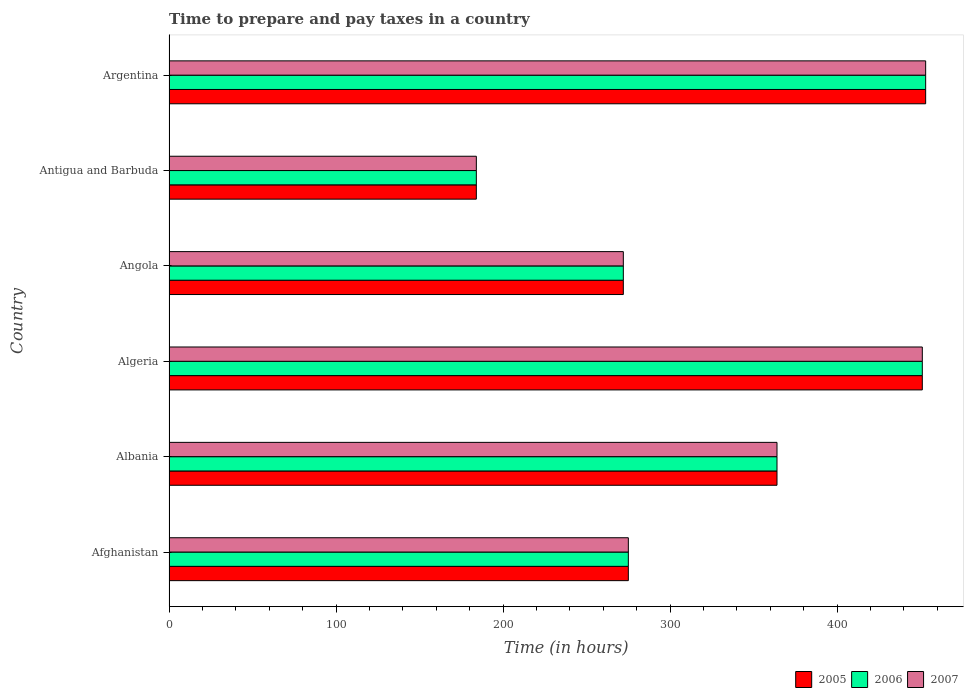How many different coloured bars are there?
Your answer should be compact. 3. How many groups of bars are there?
Offer a very short reply. 6. How many bars are there on the 2nd tick from the bottom?
Offer a terse response. 3. What is the label of the 4th group of bars from the top?
Ensure brevity in your answer.  Algeria. In how many cases, is the number of bars for a given country not equal to the number of legend labels?
Provide a short and direct response. 0. What is the number of hours required to prepare and pay taxes in 2005 in Argentina?
Provide a succinct answer. 453. Across all countries, what is the maximum number of hours required to prepare and pay taxes in 2006?
Offer a very short reply. 453. Across all countries, what is the minimum number of hours required to prepare and pay taxes in 2006?
Provide a succinct answer. 184. In which country was the number of hours required to prepare and pay taxes in 2006 minimum?
Keep it short and to the point. Antigua and Barbuda. What is the total number of hours required to prepare and pay taxes in 2005 in the graph?
Offer a very short reply. 1999. What is the difference between the number of hours required to prepare and pay taxes in 2007 in Angola and that in Argentina?
Your answer should be very brief. -181. What is the difference between the number of hours required to prepare and pay taxes in 2006 in Algeria and the number of hours required to prepare and pay taxes in 2007 in Angola?
Make the answer very short. 179. What is the average number of hours required to prepare and pay taxes in 2007 per country?
Your answer should be compact. 333.17. In how many countries, is the number of hours required to prepare and pay taxes in 2005 greater than 360 hours?
Keep it short and to the point. 3. What is the ratio of the number of hours required to prepare and pay taxes in 2005 in Afghanistan to that in Argentina?
Provide a short and direct response. 0.61. What is the difference between the highest and the lowest number of hours required to prepare and pay taxes in 2007?
Offer a terse response. 269. Is the sum of the number of hours required to prepare and pay taxes in 2007 in Afghanistan and Argentina greater than the maximum number of hours required to prepare and pay taxes in 2005 across all countries?
Offer a very short reply. Yes. What does the 1st bar from the top in Antigua and Barbuda represents?
Give a very brief answer. 2007. How many bars are there?
Your response must be concise. 18. Are all the bars in the graph horizontal?
Ensure brevity in your answer.  Yes. How many countries are there in the graph?
Offer a terse response. 6. What is the difference between two consecutive major ticks on the X-axis?
Keep it short and to the point. 100. Does the graph contain any zero values?
Offer a terse response. No. Where does the legend appear in the graph?
Provide a succinct answer. Bottom right. How are the legend labels stacked?
Make the answer very short. Horizontal. What is the title of the graph?
Your answer should be compact. Time to prepare and pay taxes in a country. What is the label or title of the X-axis?
Your answer should be compact. Time (in hours). What is the label or title of the Y-axis?
Give a very brief answer. Country. What is the Time (in hours) in 2005 in Afghanistan?
Make the answer very short. 275. What is the Time (in hours) of 2006 in Afghanistan?
Keep it short and to the point. 275. What is the Time (in hours) of 2007 in Afghanistan?
Offer a terse response. 275. What is the Time (in hours) in 2005 in Albania?
Provide a succinct answer. 364. What is the Time (in hours) of 2006 in Albania?
Provide a short and direct response. 364. What is the Time (in hours) in 2007 in Albania?
Offer a very short reply. 364. What is the Time (in hours) of 2005 in Algeria?
Provide a short and direct response. 451. What is the Time (in hours) in 2006 in Algeria?
Provide a succinct answer. 451. What is the Time (in hours) in 2007 in Algeria?
Ensure brevity in your answer.  451. What is the Time (in hours) in 2005 in Angola?
Provide a succinct answer. 272. What is the Time (in hours) of 2006 in Angola?
Provide a short and direct response. 272. What is the Time (in hours) of 2007 in Angola?
Ensure brevity in your answer.  272. What is the Time (in hours) of 2005 in Antigua and Barbuda?
Your response must be concise. 184. What is the Time (in hours) in 2006 in Antigua and Barbuda?
Your answer should be compact. 184. What is the Time (in hours) of 2007 in Antigua and Barbuda?
Offer a terse response. 184. What is the Time (in hours) in 2005 in Argentina?
Offer a terse response. 453. What is the Time (in hours) in 2006 in Argentina?
Offer a terse response. 453. What is the Time (in hours) in 2007 in Argentina?
Offer a very short reply. 453. Across all countries, what is the maximum Time (in hours) of 2005?
Give a very brief answer. 453. Across all countries, what is the maximum Time (in hours) in 2006?
Offer a terse response. 453. Across all countries, what is the maximum Time (in hours) of 2007?
Provide a short and direct response. 453. Across all countries, what is the minimum Time (in hours) of 2005?
Make the answer very short. 184. Across all countries, what is the minimum Time (in hours) in 2006?
Your response must be concise. 184. Across all countries, what is the minimum Time (in hours) of 2007?
Provide a succinct answer. 184. What is the total Time (in hours) of 2005 in the graph?
Your response must be concise. 1999. What is the total Time (in hours) of 2006 in the graph?
Offer a terse response. 1999. What is the total Time (in hours) of 2007 in the graph?
Give a very brief answer. 1999. What is the difference between the Time (in hours) in 2005 in Afghanistan and that in Albania?
Offer a very short reply. -89. What is the difference between the Time (in hours) of 2006 in Afghanistan and that in Albania?
Give a very brief answer. -89. What is the difference between the Time (in hours) in 2007 in Afghanistan and that in Albania?
Give a very brief answer. -89. What is the difference between the Time (in hours) in 2005 in Afghanistan and that in Algeria?
Your answer should be compact. -176. What is the difference between the Time (in hours) in 2006 in Afghanistan and that in Algeria?
Give a very brief answer. -176. What is the difference between the Time (in hours) of 2007 in Afghanistan and that in Algeria?
Offer a very short reply. -176. What is the difference between the Time (in hours) in 2007 in Afghanistan and that in Angola?
Your answer should be compact. 3. What is the difference between the Time (in hours) in 2005 in Afghanistan and that in Antigua and Barbuda?
Offer a very short reply. 91. What is the difference between the Time (in hours) of 2006 in Afghanistan and that in Antigua and Barbuda?
Your response must be concise. 91. What is the difference between the Time (in hours) in 2007 in Afghanistan and that in Antigua and Barbuda?
Your response must be concise. 91. What is the difference between the Time (in hours) in 2005 in Afghanistan and that in Argentina?
Offer a very short reply. -178. What is the difference between the Time (in hours) in 2006 in Afghanistan and that in Argentina?
Make the answer very short. -178. What is the difference between the Time (in hours) in 2007 in Afghanistan and that in Argentina?
Offer a very short reply. -178. What is the difference between the Time (in hours) in 2005 in Albania and that in Algeria?
Keep it short and to the point. -87. What is the difference between the Time (in hours) in 2006 in Albania and that in Algeria?
Offer a terse response. -87. What is the difference between the Time (in hours) of 2007 in Albania and that in Algeria?
Your response must be concise. -87. What is the difference between the Time (in hours) of 2005 in Albania and that in Angola?
Provide a succinct answer. 92. What is the difference between the Time (in hours) in 2006 in Albania and that in Angola?
Keep it short and to the point. 92. What is the difference between the Time (in hours) of 2007 in Albania and that in Angola?
Your answer should be very brief. 92. What is the difference between the Time (in hours) in 2005 in Albania and that in Antigua and Barbuda?
Your response must be concise. 180. What is the difference between the Time (in hours) in 2006 in Albania and that in Antigua and Barbuda?
Make the answer very short. 180. What is the difference between the Time (in hours) of 2007 in Albania and that in Antigua and Barbuda?
Give a very brief answer. 180. What is the difference between the Time (in hours) in 2005 in Albania and that in Argentina?
Your response must be concise. -89. What is the difference between the Time (in hours) of 2006 in Albania and that in Argentina?
Your response must be concise. -89. What is the difference between the Time (in hours) in 2007 in Albania and that in Argentina?
Ensure brevity in your answer.  -89. What is the difference between the Time (in hours) in 2005 in Algeria and that in Angola?
Your answer should be compact. 179. What is the difference between the Time (in hours) of 2006 in Algeria and that in Angola?
Offer a terse response. 179. What is the difference between the Time (in hours) of 2007 in Algeria and that in Angola?
Provide a short and direct response. 179. What is the difference between the Time (in hours) of 2005 in Algeria and that in Antigua and Barbuda?
Offer a terse response. 267. What is the difference between the Time (in hours) in 2006 in Algeria and that in Antigua and Barbuda?
Offer a terse response. 267. What is the difference between the Time (in hours) of 2007 in Algeria and that in Antigua and Barbuda?
Your response must be concise. 267. What is the difference between the Time (in hours) of 2005 in Angola and that in Argentina?
Your response must be concise. -181. What is the difference between the Time (in hours) of 2006 in Angola and that in Argentina?
Offer a terse response. -181. What is the difference between the Time (in hours) in 2007 in Angola and that in Argentina?
Provide a succinct answer. -181. What is the difference between the Time (in hours) in 2005 in Antigua and Barbuda and that in Argentina?
Your answer should be compact. -269. What is the difference between the Time (in hours) in 2006 in Antigua and Barbuda and that in Argentina?
Provide a short and direct response. -269. What is the difference between the Time (in hours) of 2007 in Antigua and Barbuda and that in Argentina?
Keep it short and to the point. -269. What is the difference between the Time (in hours) of 2005 in Afghanistan and the Time (in hours) of 2006 in Albania?
Keep it short and to the point. -89. What is the difference between the Time (in hours) in 2005 in Afghanistan and the Time (in hours) in 2007 in Albania?
Ensure brevity in your answer.  -89. What is the difference between the Time (in hours) of 2006 in Afghanistan and the Time (in hours) of 2007 in Albania?
Ensure brevity in your answer.  -89. What is the difference between the Time (in hours) in 2005 in Afghanistan and the Time (in hours) in 2006 in Algeria?
Provide a succinct answer. -176. What is the difference between the Time (in hours) of 2005 in Afghanistan and the Time (in hours) of 2007 in Algeria?
Offer a very short reply. -176. What is the difference between the Time (in hours) of 2006 in Afghanistan and the Time (in hours) of 2007 in Algeria?
Your answer should be compact. -176. What is the difference between the Time (in hours) in 2006 in Afghanistan and the Time (in hours) in 2007 in Angola?
Provide a succinct answer. 3. What is the difference between the Time (in hours) in 2005 in Afghanistan and the Time (in hours) in 2006 in Antigua and Barbuda?
Offer a very short reply. 91. What is the difference between the Time (in hours) in 2005 in Afghanistan and the Time (in hours) in 2007 in Antigua and Barbuda?
Your answer should be compact. 91. What is the difference between the Time (in hours) of 2006 in Afghanistan and the Time (in hours) of 2007 in Antigua and Barbuda?
Your answer should be compact. 91. What is the difference between the Time (in hours) of 2005 in Afghanistan and the Time (in hours) of 2006 in Argentina?
Your response must be concise. -178. What is the difference between the Time (in hours) in 2005 in Afghanistan and the Time (in hours) in 2007 in Argentina?
Offer a very short reply. -178. What is the difference between the Time (in hours) in 2006 in Afghanistan and the Time (in hours) in 2007 in Argentina?
Make the answer very short. -178. What is the difference between the Time (in hours) in 2005 in Albania and the Time (in hours) in 2006 in Algeria?
Your answer should be very brief. -87. What is the difference between the Time (in hours) in 2005 in Albania and the Time (in hours) in 2007 in Algeria?
Your answer should be compact. -87. What is the difference between the Time (in hours) of 2006 in Albania and the Time (in hours) of 2007 in Algeria?
Your answer should be very brief. -87. What is the difference between the Time (in hours) of 2005 in Albania and the Time (in hours) of 2006 in Angola?
Ensure brevity in your answer.  92. What is the difference between the Time (in hours) in 2005 in Albania and the Time (in hours) in 2007 in Angola?
Your response must be concise. 92. What is the difference between the Time (in hours) of 2006 in Albania and the Time (in hours) of 2007 in Angola?
Ensure brevity in your answer.  92. What is the difference between the Time (in hours) of 2005 in Albania and the Time (in hours) of 2006 in Antigua and Barbuda?
Give a very brief answer. 180. What is the difference between the Time (in hours) in 2005 in Albania and the Time (in hours) in 2007 in Antigua and Barbuda?
Your response must be concise. 180. What is the difference between the Time (in hours) in 2006 in Albania and the Time (in hours) in 2007 in Antigua and Barbuda?
Give a very brief answer. 180. What is the difference between the Time (in hours) of 2005 in Albania and the Time (in hours) of 2006 in Argentina?
Offer a very short reply. -89. What is the difference between the Time (in hours) of 2005 in Albania and the Time (in hours) of 2007 in Argentina?
Your answer should be compact. -89. What is the difference between the Time (in hours) of 2006 in Albania and the Time (in hours) of 2007 in Argentina?
Provide a short and direct response. -89. What is the difference between the Time (in hours) of 2005 in Algeria and the Time (in hours) of 2006 in Angola?
Your response must be concise. 179. What is the difference between the Time (in hours) in 2005 in Algeria and the Time (in hours) in 2007 in Angola?
Give a very brief answer. 179. What is the difference between the Time (in hours) in 2006 in Algeria and the Time (in hours) in 2007 in Angola?
Give a very brief answer. 179. What is the difference between the Time (in hours) of 2005 in Algeria and the Time (in hours) of 2006 in Antigua and Barbuda?
Give a very brief answer. 267. What is the difference between the Time (in hours) of 2005 in Algeria and the Time (in hours) of 2007 in Antigua and Barbuda?
Your answer should be compact. 267. What is the difference between the Time (in hours) of 2006 in Algeria and the Time (in hours) of 2007 in Antigua and Barbuda?
Your answer should be compact. 267. What is the difference between the Time (in hours) of 2005 in Algeria and the Time (in hours) of 2007 in Argentina?
Ensure brevity in your answer.  -2. What is the difference between the Time (in hours) in 2006 in Algeria and the Time (in hours) in 2007 in Argentina?
Provide a short and direct response. -2. What is the difference between the Time (in hours) of 2005 in Angola and the Time (in hours) of 2006 in Antigua and Barbuda?
Your answer should be compact. 88. What is the difference between the Time (in hours) of 2005 in Angola and the Time (in hours) of 2007 in Antigua and Barbuda?
Your answer should be compact. 88. What is the difference between the Time (in hours) of 2005 in Angola and the Time (in hours) of 2006 in Argentina?
Offer a terse response. -181. What is the difference between the Time (in hours) in 2005 in Angola and the Time (in hours) in 2007 in Argentina?
Provide a succinct answer. -181. What is the difference between the Time (in hours) of 2006 in Angola and the Time (in hours) of 2007 in Argentina?
Your answer should be very brief. -181. What is the difference between the Time (in hours) in 2005 in Antigua and Barbuda and the Time (in hours) in 2006 in Argentina?
Give a very brief answer. -269. What is the difference between the Time (in hours) in 2005 in Antigua and Barbuda and the Time (in hours) in 2007 in Argentina?
Provide a succinct answer. -269. What is the difference between the Time (in hours) in 2006 in Antigua and Barbuda and the Time (in hours) in 2007 in Argentina?
Your response must be concise. -269. What is the average Time (in hours) of 2005 per country?
Provide a short and direct response. 333.17. What is the average Time (in hours) in 2006 per country?
Your answer should be very brief. 333.17. What is the average Time (in hours) in 2007 per country?
Your answer should be compact. 333.17. What is the difference between the Time (in hours) in 2006 and Time (in hours) in 2007 in Afghanistan?
Your response must be concise. 0. What is the difference between the Time (in hours) in 2005 and Time (in hours) in 2006 in Albania?
Ensure brevity in your answer.  0. What is the difference between the Time (in hours) of 2005 and Time (in hours) of 2007 in Albania?
Keep it short and to the point. 0. What is the difference between the Time (in hours) in 2006 and Time (in hours) in 2007 in Angola?
Offer a terse response. 0. What is the difference between the Time (in hours) in 2005 and Time (in hours) in 2006 in Antigua and Barbuda?
Ensure brevity in your answer.  0. What is the difference between the Time (in hours) of 2005 and Time (in hours) of 2007 in Antigua and Barbuda?
Keep it short and to the point. 0. What is the difference between the Time (in hours) in 2006 and Time (in hours) in 2007 in Antigua and Barbuda?
Offer a very short reply. 0. What is the difference between the Time (in hours) of 2005 and Time (in hours) of 2007 in Argentina?
Your answer should be very brief. 0. What is the ratio of the Time (in hours) of 2005 in Afghanistan to that in Albania?
Your response must be concise. 0.76. What is the ratio of the Time (in hours) of 2006 in Afghanistan to that in Albania?
Your response must be concise. 0.76. What is the ratio of the Time (in hours) of 2007 in Afghanistan to that in Albania?
Your response must be concise. 0.76. What is the ratio of the Time (in hours) in 2005 in Afghanistan to that in Algeria?
Give a very brief answer. 0.61. What is the ratio of the Time (in hours) in 2006 in Afghanistan to that in Algeria?
Your answer should be compact. 0.61. What is the ratio of the Time (in hours) in 2007 in Afghanistan to that in Algeria?
Your answer should be very brief. 0.61. What is the ratio of the Time (in hours) of 2005 in Afghanistan to that in Angola?
Give a very brief answer. 1.01. What is the ratio of the Time (in hours) of 2005 in Afghanistan to that in Antigua and Barbuda?
Provide a succinct answer. 1.49. What is the ratio of the Time (in hours) in 2006 in Afghanistan to that in Antigua and Barbuda?
Your response must be concise. 1.49. What is the ratio of the Time (in hours) of 2007 in Afghanistan to that in Antigua and Barbuda?
Offer a very short reply. 1.49. What is the ratio of the Time (in hours) of 2005 in Afghanistan to that in Argentina?
Ensure brevity in your answer.  0.61. What is the ratio of the Time (in hours) of 2006 in Afghanistan to that in Argentina?
Your response must be concise. 0.61. What is the ratio of the Time (in hours) in 2007 in Afghanistan to that in Argentina?
Make the answer very short. 0.61. What is the ratio of the Time (in hours) in 2005 in Albania to that in Algeria?
Provide a short and direct response. 0.81. What is the ratio of the Time (in hours) in 2006 in Albania to that in Algeria?
Provide a succinct answer. 0.81. What is the ratio of the Time (in hours) in 2007 in Albania to that in Algeria?
Provide a short and direct response. 0.81. What is the ratio of the Time (in hours) in 2005 in Albania to that in Angola?
Keep it short and to the point. 1.34. What is the ratio of the Time (in hours) in 2006 in Albania to that in Angola?
Make the answer very short. 1.34. What is the ratio of the Time (in hours) in 2007 in Albania to that in Angola?
Your answer should be very brief. 1.34. What is the ratio of the Time (in hours) of 2005 in Albania to that in Antigua and Barbuda?
Your answer should be compact. 1.98. What is the ratio of the Time (in hours) in 2006 in Albania to that in Antigua and Barbuda?
Provide a short and direct response. 1.98. What is the ratio of the Time (in hours) of 2007 in Albania to that in Antigua and Barbuda?
Keep it short and to the point. 1.98. What is the ratio of the Time (in hours) in 2005 in Albania to that in Argentina?
Ensure brevity in your answer.  0.8. What is the ratio of the Time (in hours) in 2006 in Albania to that in Argentina?
Ensure brevity in your answer.  0.8. What is the ratio of the Time (in hours) in 2007 in Albania to that in Argentina?
Keep it short and to the point. 0.8. What is the ratio of the Time (in hours) of 2005 in Algeria to that in Angola?
Offer a very short reply. 1.66. What is the ratio of the Time (in hours) of 2006 in Algeria to that in Angola?
Make the answer very short. 1.66. What is the ratio of the Time (in hours) in 2007 in Algeria to that in Angola?
Offer a very short reply. 1.66. What is the ratio of the Time (in hours) of 2005 in Algeria to that in Antigua and Barbuda?
Make the answer very short. 2.45. What is the ratio of the Time (in hours) of 2006 in Algeria to that in Antigua and Barbuda?
Make the answer very short. 2.45. What is the ratio of the Time (in hours) in 2007 in Algeria to that in Antigua and Barbuda?
Offer a terse response. 2.45. What is the ratio of the Time (in hours) in 2005 in Algeria to that in Argentina?
Provide a short and direct response. 1. What is the ratio of the Time (in hours) of 2005 in Angola to that in Antigua and Barbuda?
Give a very brief answer. 1.48. What is the ratio of the Time (in hours) in 2006 in Angola to that in Antigua and Barbuda?
Ensure brevity in your answer.  1.48. What is the ratio of the Time (in hours) of 2007 in Angola to that in Antigua and Barbuda?
Ensure brevity in your answer.  1.48. What is the ratio of the Time (in hours) of 2005 in Angola to that in Argentina?
Your answer should be very brief. 0.6. What is the ratio of the Time (in hours) in 2006 in Angola to that in Argentina?
Give a very brief answer. 0.6. What is the ratio of the Time (in hours) in 2007 in Angola to that in Argentina?
Keep it short and to the point. 0.6. What is the ratio of the Time (in hours) in 2005 in Antigua and Barbuda to that in Argentina?
Provide a succinct answer. 0.41. What is the ratio of the Time (in hours) of 2006 in Antigua and Barbuda to that in Argentina?
Your answer should be compact. 0.41. What is the ratio of the Time (in hours) of 2007 in Antigua and Barbuda to that in Argentina?
Keep it short and to the point. 0.41. What is the difference between the highest and the second highest Time (in hours) in 2006?
Your answer should be compact. 2. What is the difference between the highest and the lowest Time (in hours) of 2005?
Provide a succinct answer. 269. What is the difference between the highest and the lowest Time (in hours) of 2006?
Your answer should be very brief. 269. What is the difference between the highest and the lowest Time (in hours) of 2007?
Give a very brief answer. 269. 